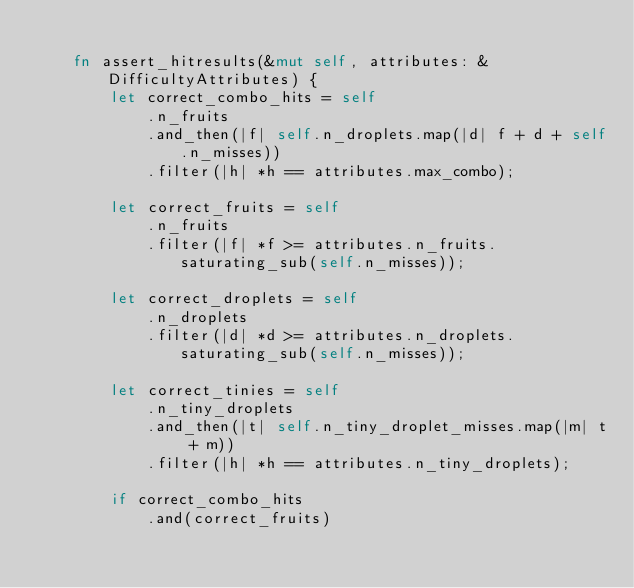Convert code to text. <code><loc_0><loc_0><loc_500><loc_500><_Rust_>
    fn assert_hitresults(&mut self, attributes: &DifficultyAttributes) {
        let correct_combo_hits = self
            .n_fruits
            .and_then(|f| self.n_droplets.map(|d| f + d + self.n_misses))
            .filter(|h| *h == attributes.max_combo);

        let correct_fruits = self
            .n_fruits
            .filter(|f| *f >= attributes.n_fruits.saturating_sub(self.n_misses));

        let correct_droplets = self
            .n_droplets
            .filter(|d| *d >= attributes.n_droplets.saturating_sub(self.n_misses));

        let correct_tinies = self
            .n_tiny_droplets
            .and_then(|t| self.n_tiny_droplet_misses.map(|m| t + m))
            .filter(|h| *h == attributes.n_tiny_droplets);

        if correct_combo_hits
            .and(correct_fruits)</code> 